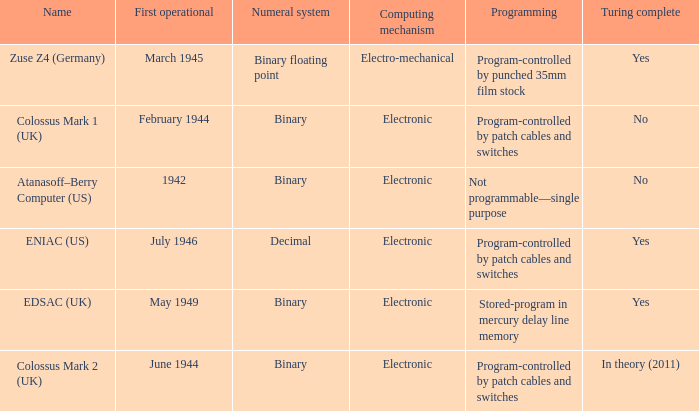How does turing completeness relate to a decimal numeral system? Yes. 